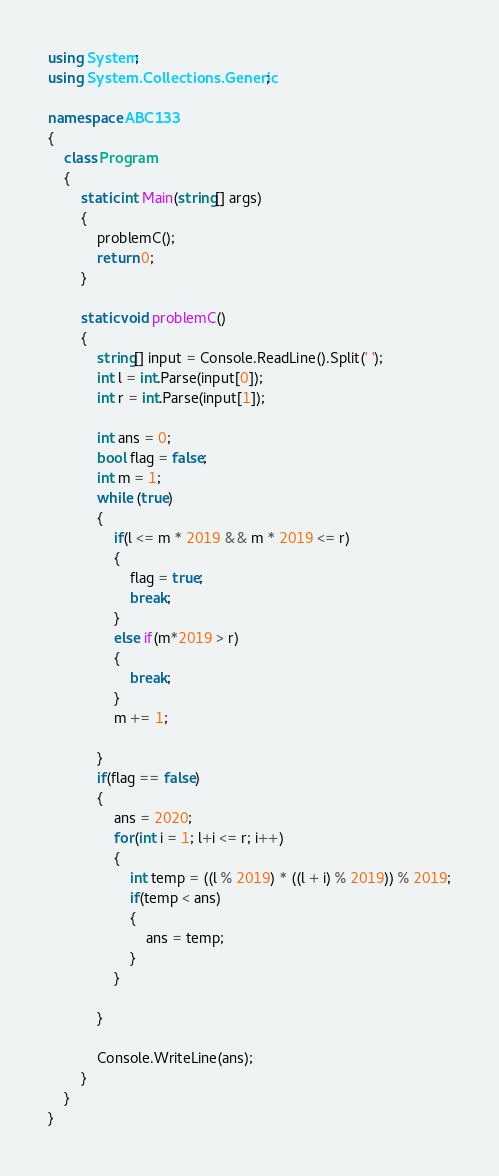<code> <loc_0><loc_0><loc_500><loc_500><_C#_>using System;
using System.Collections.Generic;

namespace ABC133
{
    class Program
    {
        static int Main(string[] args)
        {
            problemC();
            return 0;
        }

        static void problemC()
        {
            string[] input = Console.ReadLine().Split(' ');
            int l = int.Parse(input[0]);
            int r = int.Parse(input[1]);

            int ans = 0;
            bool flag = false;
            int m = 1;
            while (true)
            {
                if(l <= m * 2019 && m * 2019 <= r)
                {
                    flag = true;
                    break;
                }
                else if(m*2019 > r)
                {
                    break;
                }
                m += 1;
                
            }
            if(flag == false)
            {
                ans = 2020;
                for(int i = 1; l+i <= r; i++)
                {
                    int temp = ((l % 2019) * ((l + i) % 2019)) % 2019;
                    if(temp < ans)
                    {
                        ans = temp;
                    }
                }
                
            }

            Console.WriteLine(ans);
        }
    }
}</code> 